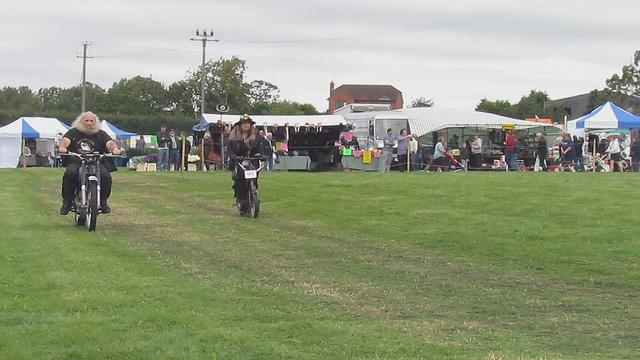What type food is more likely served here? hot dog 